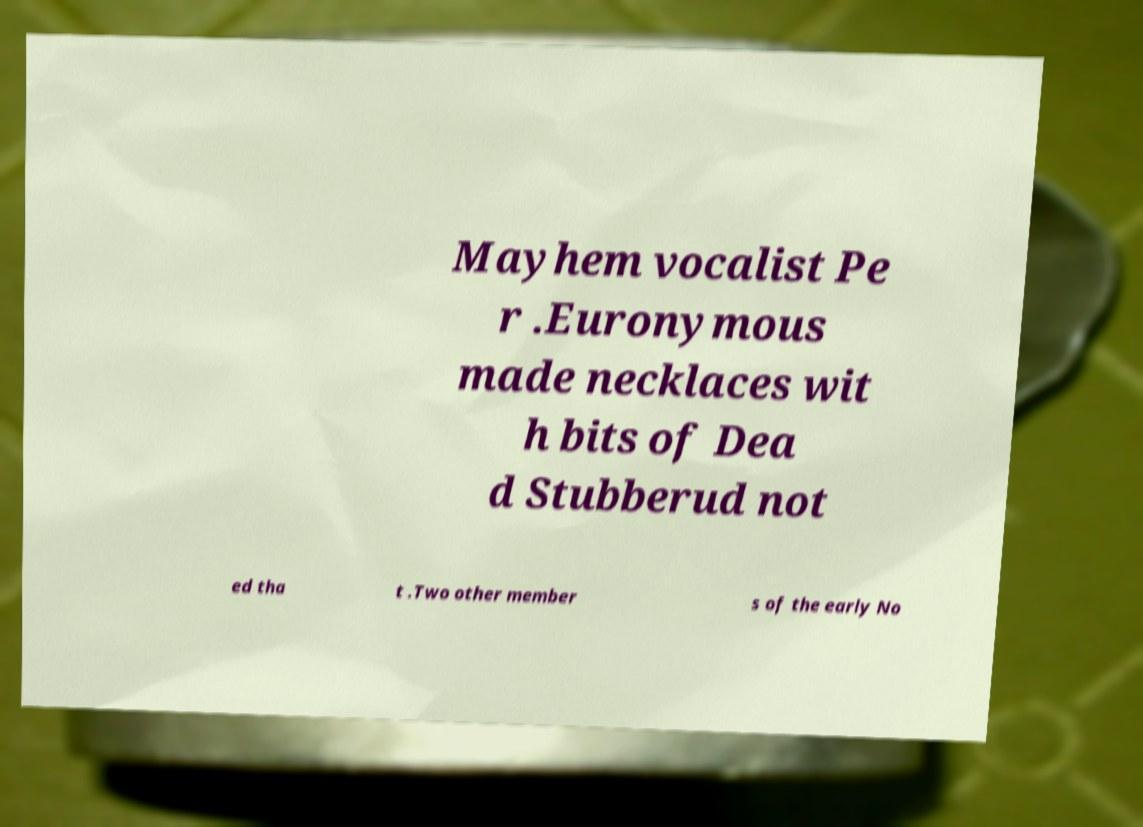Can you accurately transcribe the text from the provided image for me? Mayhem vocalist Pe r .Euronymous made necklaces wit h bits of Dea d Stubberud not ed tha t .Two other member s of the early No 